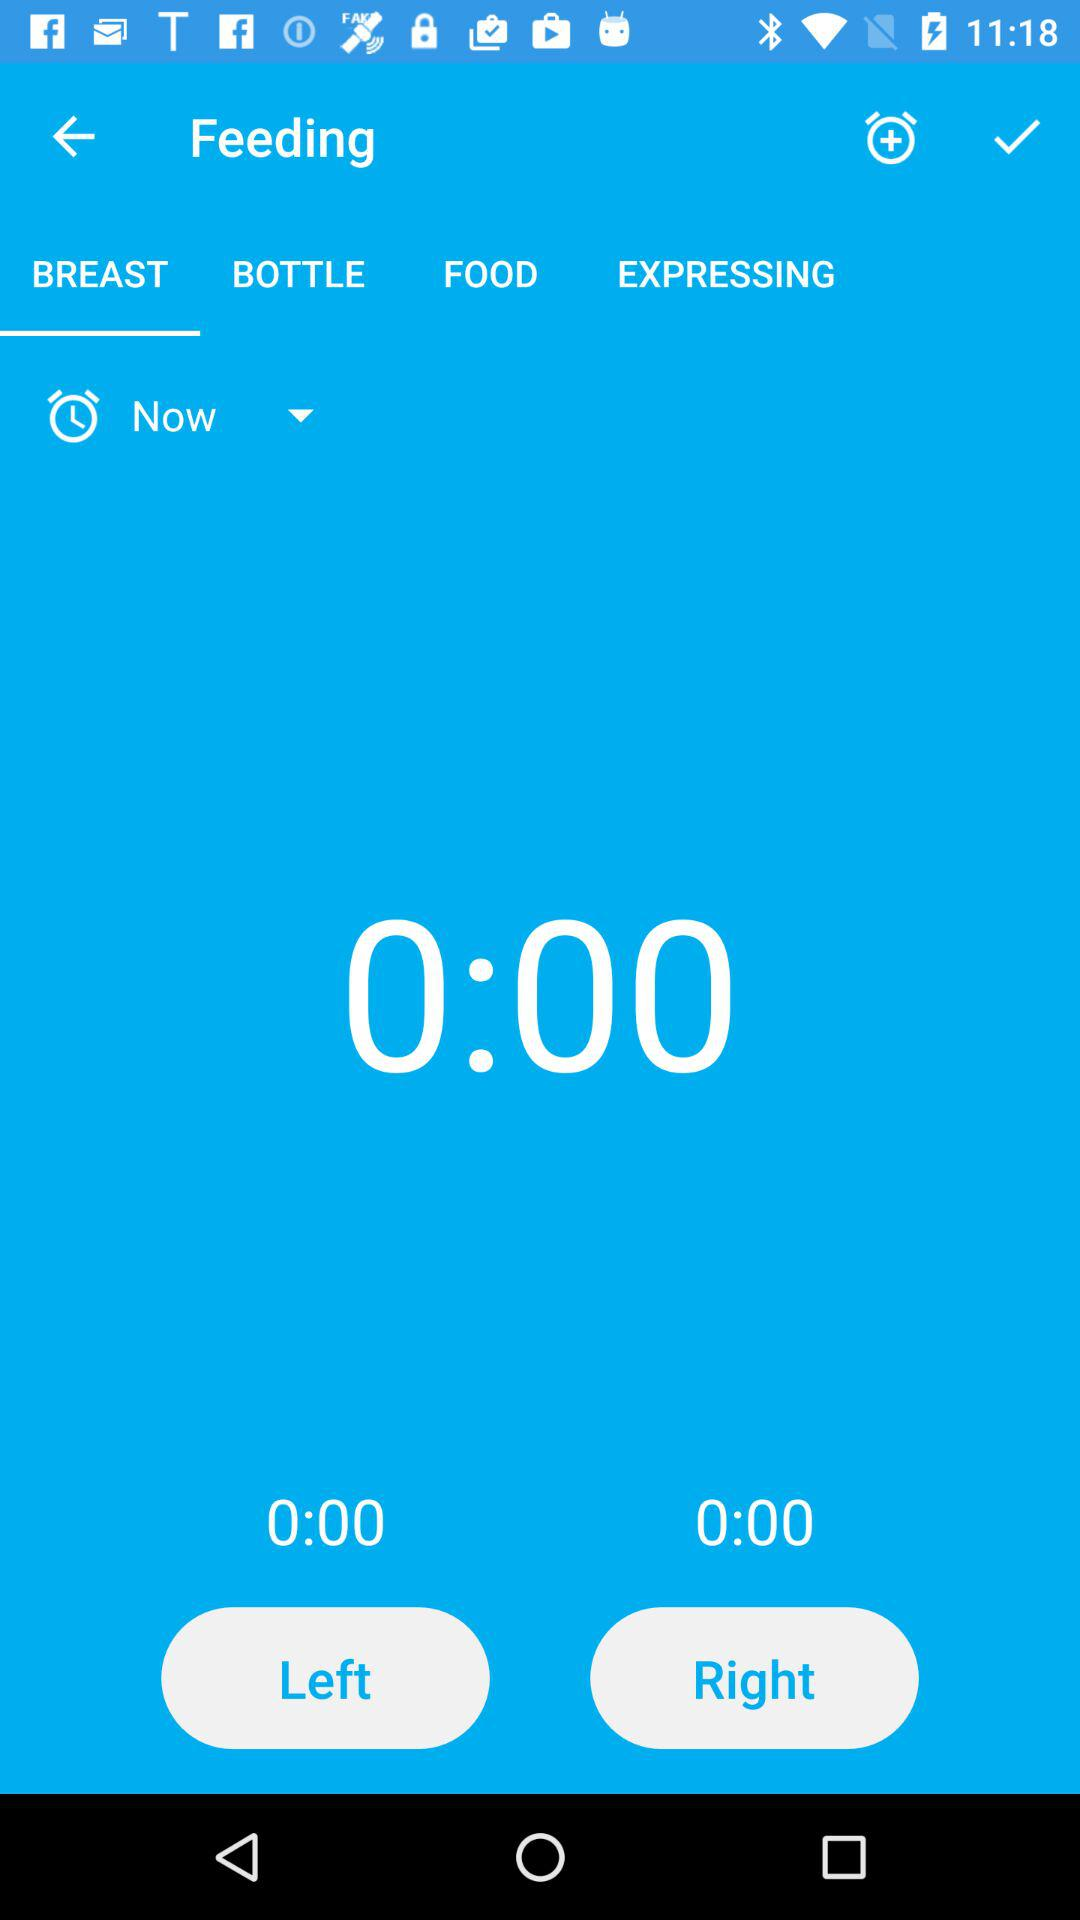What's the timer on the screen?
When the provided information is insufficient, respond with <no answer>. <no answer> 